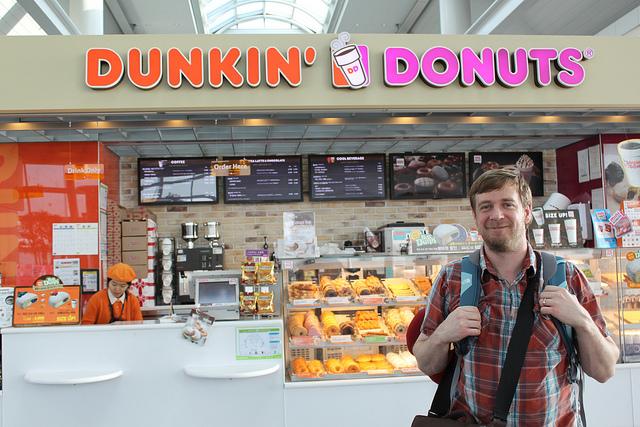What kind of store is this?
Give a very brief answer. Dunkin donuts. How many people are in this photo?
Quick response, please. 2. What would happen if you ate a large amount of this kind of food for a long time?
Quick response, please. You would get fat. What season does it look like they are in?
Quick response, please. Summer. How many people are behind the counter, working?
Write a very short answer. 1. 